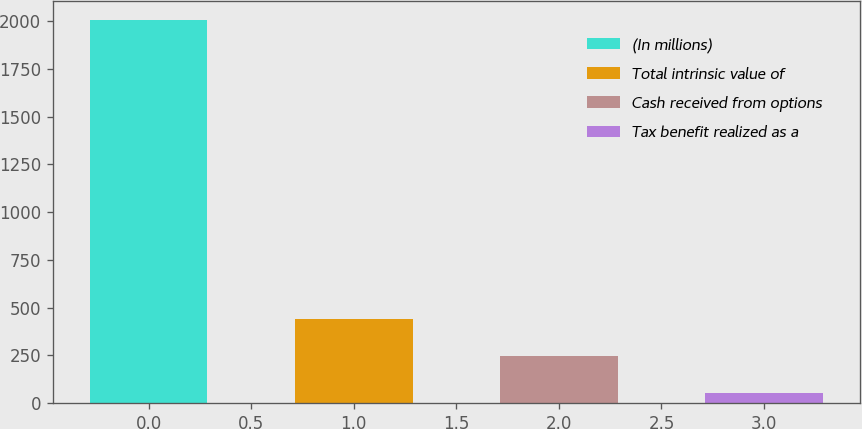<chart> <loc_0><loc_0><loc_500><loc_500><bar_chart><fcel>(In millions)<fcel>Total intrinsic value of<fcel>Cash received from options<fcel>Tax benefit realized as a<nl><fcel>2007<fcel>442.2<fcel>246.6<fcel>51<nl></chart> 